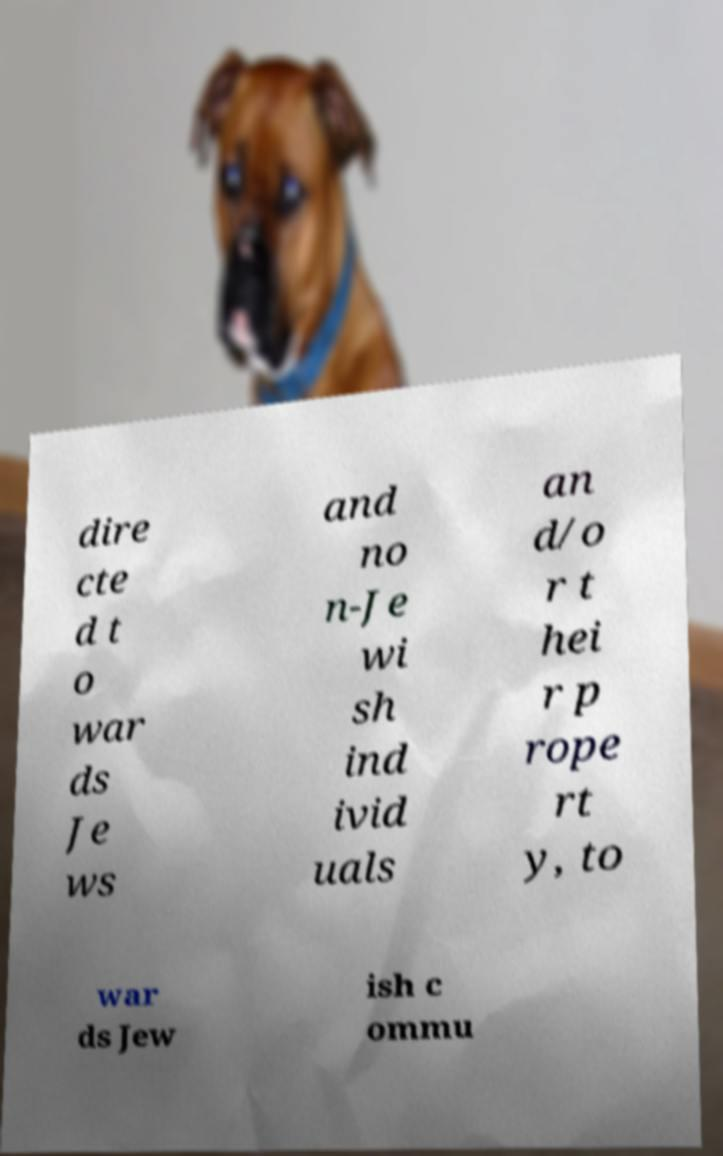I need the written content from this picture converted into text. Can you do that? dire cte d t o war ds Je ws and no n-Je wi sh ind ivid uals an d/o r t hei r p rope rt y, to war ds Jew ish c ommu 